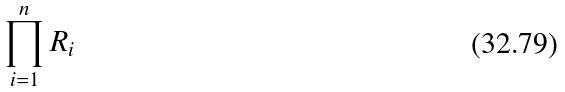<formula> <loc_0><loc_0><loc_500><loc_500>\prod _ { i = 1 } ^ { n } R _ { i }</formula> 